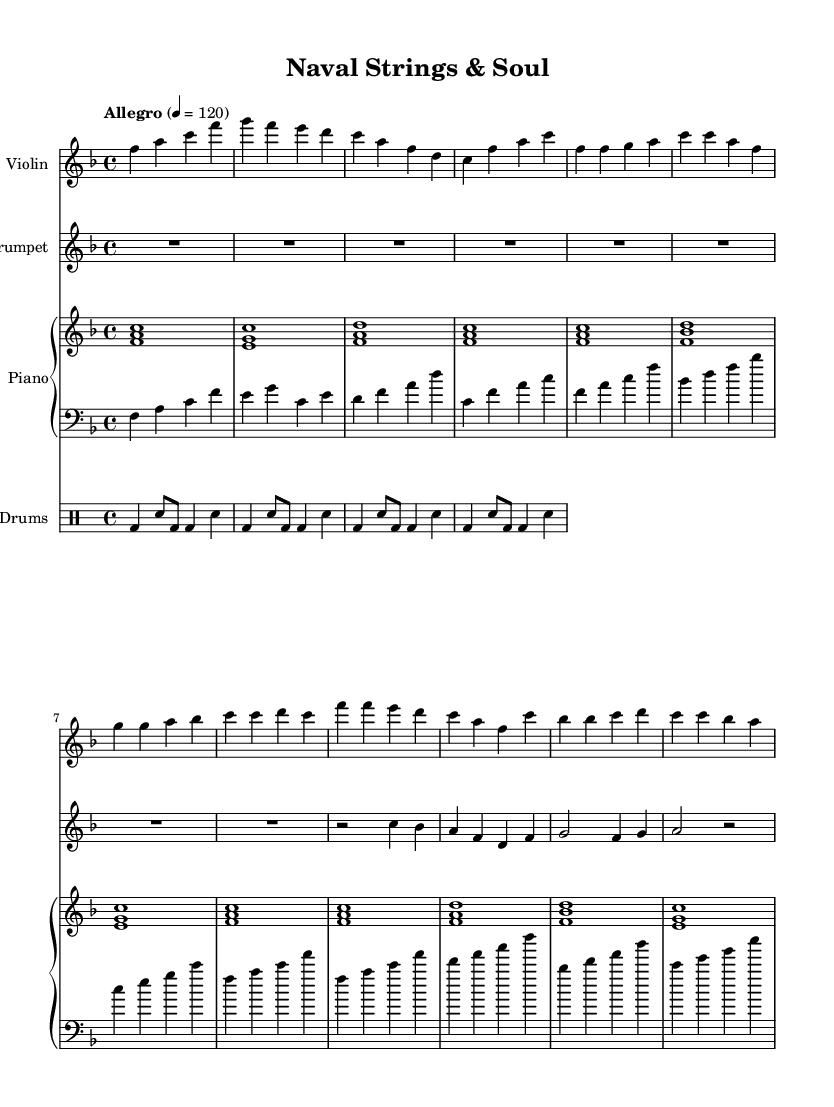What is the key signature of this music? The key signature indicates the presence of a B flat and an E flat, which means the music is in F major.
Answer: F major What is the time signature of this piece? The time signature shows four beats per measure, which can be seen as "4/4" at the beginning of the score.
Answer: 4/4 What is the tempo marking for the piece? The tempo marking "Allegro" along with a metronome marking of 120 beats per minute indicates the speed at which the piece should be played.
Answer: Allegro, 120 How many measures are there in the chorus? Counting the measures labeled as "Chorus" reveals there are four distinct measures in this section.
Answer: 4 Which instruments are featured in this composition? By examining the score, the presence of violin, trumpet, piano, bass, and drums indicates a diverse set of instruments involved in performance.
Answer: Violin, Trumpet, Piano, Bass, Drums In which section does the violin play the highest note? Looking at the violin part, the highest note is found in the chorus where it reaches a C in the fourth measure.
Answer: Chorus How does the piano contribute to the overall texture of the music? The piano plays harmonies and rhythms that complement the melody lines of the violin and trumpet, adding depth to the chamber music's overall sound.
Answer: Harmonic support 